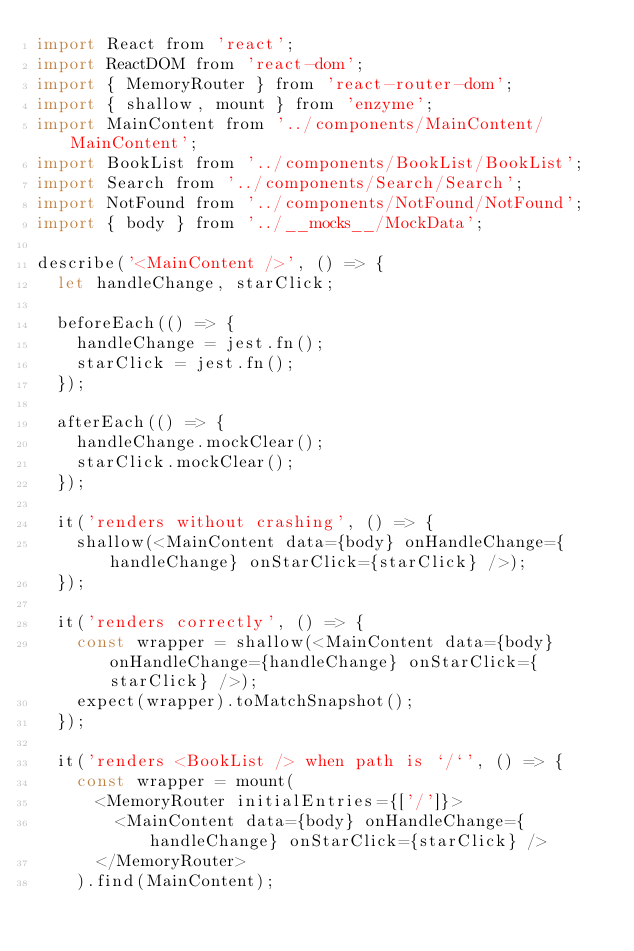<code> <loc_0><loc_0><loc_500><loc_500><_JavaScript_>import React from 'react';
import ReactDOM from 'react-dom';
import { MemoryRouter } from 'react-router-dom';
import { shallow, mount } from 'enzyme';
import MainContent from '../components/MainContent/MainContent';
import BookList from '../components/BookList/BookList';
import Search from '../components/Search/Search';
import NotFound from '../components/NotFound/NotFound';
import { body } from '../__mocks__/MockData';

describe('<MainContent />', () => {
  let handleChange, starClick;

  beforeEach(() => {
    handleChange = jest.fn();
    starClick = jest.fn();
  });

  afterEach(() => {
    handleChange.mockClear();
    starClick.mockClear();
  });

  it('renders without crashing', () => {
    shallow(<MainContent data={body} onHandleChange={handleChange} onStarClick={starClick} />);
  });

  it('renders correctly', () => {
    const wrapper = shallow(<MainContent data={body} onHandleChange={handleChange} onStarClick={starClick} />);
    expect(wrapper).toMatchSnapshot();
  });

  it('renders <BookList /> when path is `/`', () => {
    const wrapper = mount(
      <MemoryRouter initialEntries={['/']}>
        <MainContent data={body} onHandleChange={handleChange} onStarClick={starClick} />
      </MemoryRouter>
    ).find(MainContent);</code> 